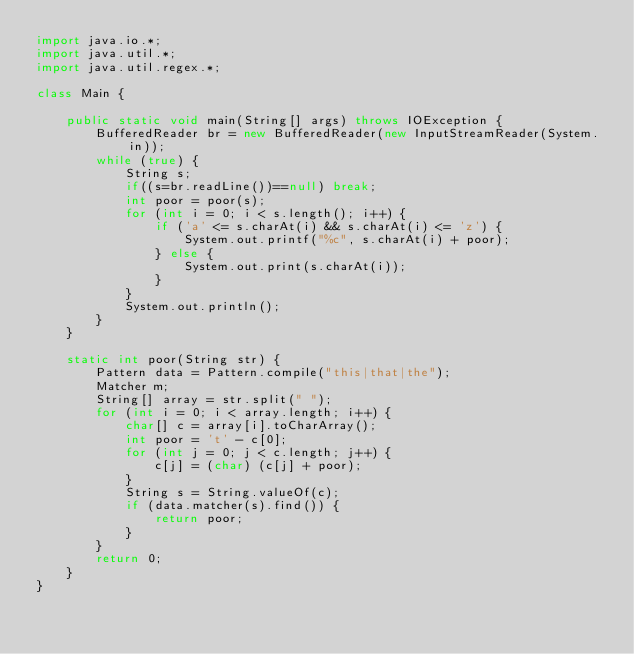<code> <loc_0><loc_0><loc_500><loc_500><_Java_>import java.io.*;
import java.util.*;
import java.util.regex.*;

class Main {

    public static void main(String[] args) throws IOException {
        BufferedReader br = new BufferedReader(new InputStreamReader(System.in));
        while (true) {
            String s;
            if((s=br.readLine())==null) break;
            int poor = poor(s);
            for (int i = 0; i < s.length(); i++) {
                if ('a' <= s.charAt(i) && s.charAt(i) <= 'z') {
                    System.out.printf("%c", s.charAt(i) + poor);
                } else {
                    System.out.print(s.charAt(i));
                }
            }
            System.out.println();
        }
    }

    static int poor(String str) {
        Pattern data = Pattern.compile("this|that|the");
        Matcher m;
        String[] array = str.split(" ");
        for (int i = 0; i < array.length; i++) {
            char[] c = array[i].toCharArray();
            int poor = 't' - c[0];
            for (int j = 0; j < c.length; j++) {
                c[j] = (char) (c[j] + poor);
            }
            String s = String.valueOf(c);
            if (data.matcher(s).find()) {
                return poor;
            }
        }
        return 0;
    }
}</code> 